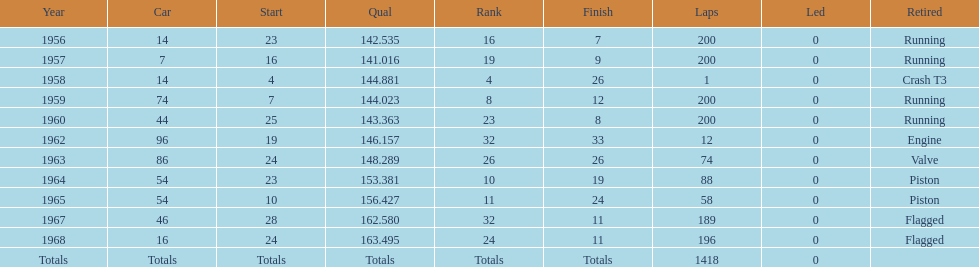What is the larger laps between 1963 or 1968 1968. 